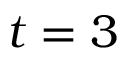Convert formula to latex. <formula><loc_0><loc_0><loc_500><loc_500>t = 3</formula> 